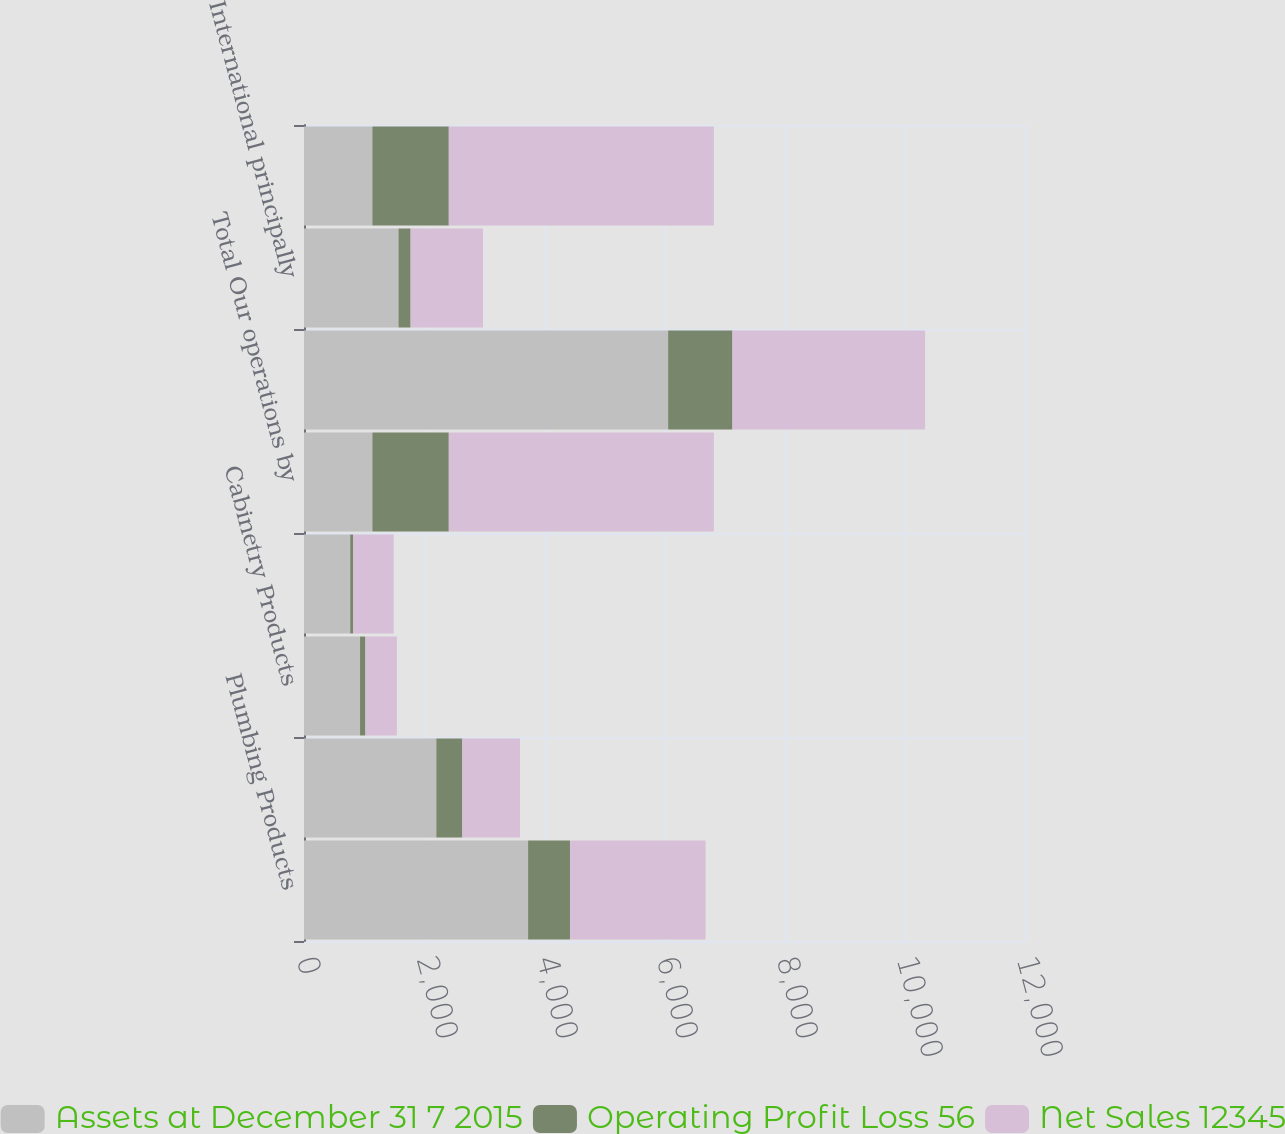<chart> <loc_0><loc_0><loc_500><loc_500><stacked_bar_chart><ecel><fcel>Plumbing Products<fcel>Decorative Architectural<fcel>Cabinetry Products<fcel>Windows and Other Specialty<fcel>Total Our operations by<fcel>were North America<fcel>International principally<fcel>Total as above<nl><fcel>Assets at December 31 7 2015<fcel>3735<fcel>2205<fcel>934<fcel>770<fcel>1139.5<fcel>6069<fcel>1575<fcel>1139.5<nl><fcel>Operating Profit Loss 56<fcel>698<fcel>434<fcel>90<fcel>52<fcel>1274<fcel>1072<fcel>202<fcel>1274<nl><fcel>Net Sales 12345<fcel>2260<fcel>961<fcel>524<fcel>673<fcel>4418<fcel>3211<fcel>1207<fcel>4418<nl></chart> 